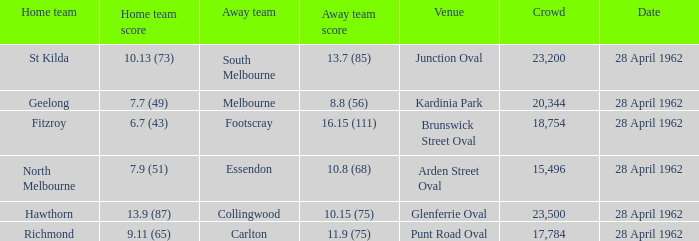At what venue did an away team score 10.15 (75)? Glenferrie Oval. 